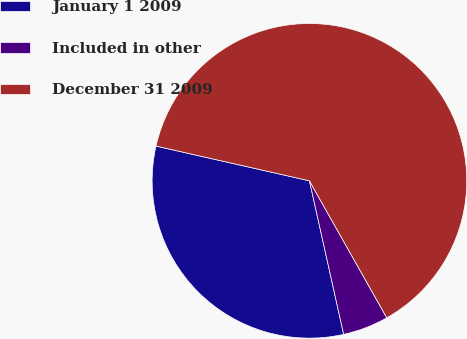Convert chart. <chart><loc_0><loc_0><loc_500><loc_500><pie_chart><fcel>January 1 2009<fcel>Included in other<fcel>December 31 2009<nl><fcel>32.03%<fcel>4.69%<fcel>63.27%<nl></chart> 